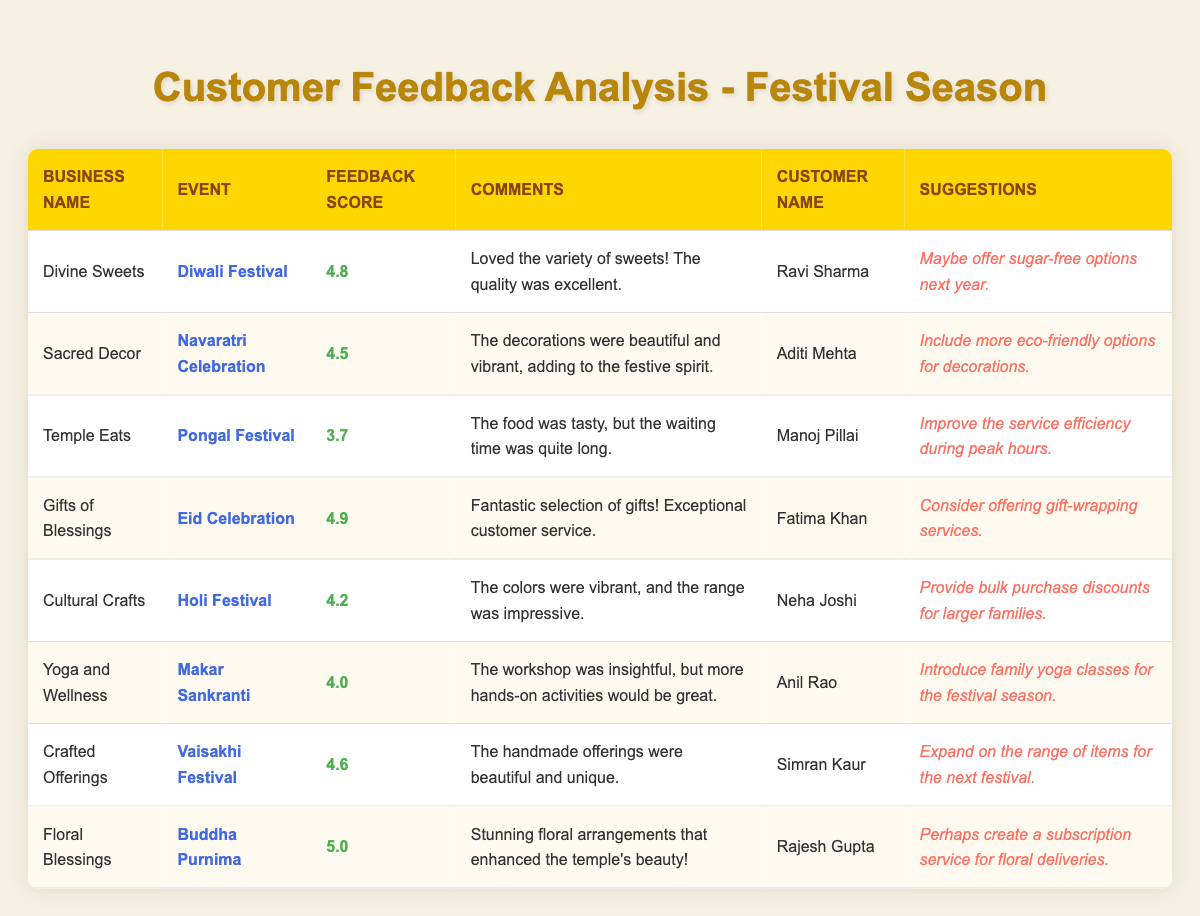What business received the highest feedback score? The table shows the feedback scores for each business. By reviewing the scores, "Floral Blessings" received the highest score of 5.0.
Answer: Floral Blessings How many businesses received a feedback score of 4.5 or higher? Counting all the businesses with scores of 4.5 or above: "Divine Sweets" (4.8), "Sacred Decor" (4.5), "Gifts of Blessings" (4.9), "Cultural Crafts" (4.2), "Crafted Offerings" (4.6), and "Floral Blessings" (5.0) totals to 6 businesses.
Answer: 6 Which customer suggested offering sugar-free options? The table indicates that the suggestion for sugar-free options was made by "Ravi Sharma" who provided feedback for "Divine Sweets."
Answer: Ravi Sharma What is the average feedback score of all businesses listed? To find the average, sum the feedback scores: 4.8 + 4.5 + 3.7 + 4.9 + 4.2 + 4.0 + 4.6 + 5.0 = 36.7. There are 8 businesses, so the average score is 36.7 / 8 = 4.5875, which rounds to 4.59.
Answer: 4.59 Did any business receive a suggestion about eco-friendly options? The feedback from "Aditi Mehta" for "Sacred Decor" included a suggestion for more eco-friendly options, confirming that at least one business received such a suggestion.
Answer: Yes Which event had the lowest feedback score? By comparing all the feedback scores in the table, the event with the lowest score is "Pongal Festival," with a score of 3.7 from "Temple Eats."
Answer: Pongal Festival What suggestion did Fatima Khan make regarding gift services? According to the feedback, "Fatima Khan" suggested that "Gifts of Blessings" consider offering gift-wrapping services.
Answer: Gift-wrapping services How many customers commented on the quality of products offered? Analyzing the comments, "Ravi Sharma," "Fatima Khan," "Neha Joshi," and "Simran Kaur" all praised the quality of sweets, gifts, colors, and handcrafted offerings, respectively, leading to a total of 4 customers commenting positively on quality.
Answer: 4 Which event had the highest feedback and which business was associated with it? The event with the highest score was "Buddha Purnima," associated with "Floral Blessings," which received a score of 5.0.
Answer: Buddha Purnima, Floral Blessings What additional suggestion did Neha Joshi provide for "Cultural Crafts"? Neha Joshi suggested providing bulk purchase discounts for larger families in her feedback about "Cultural Crafts."
Answer: Bulk purchase discounts 